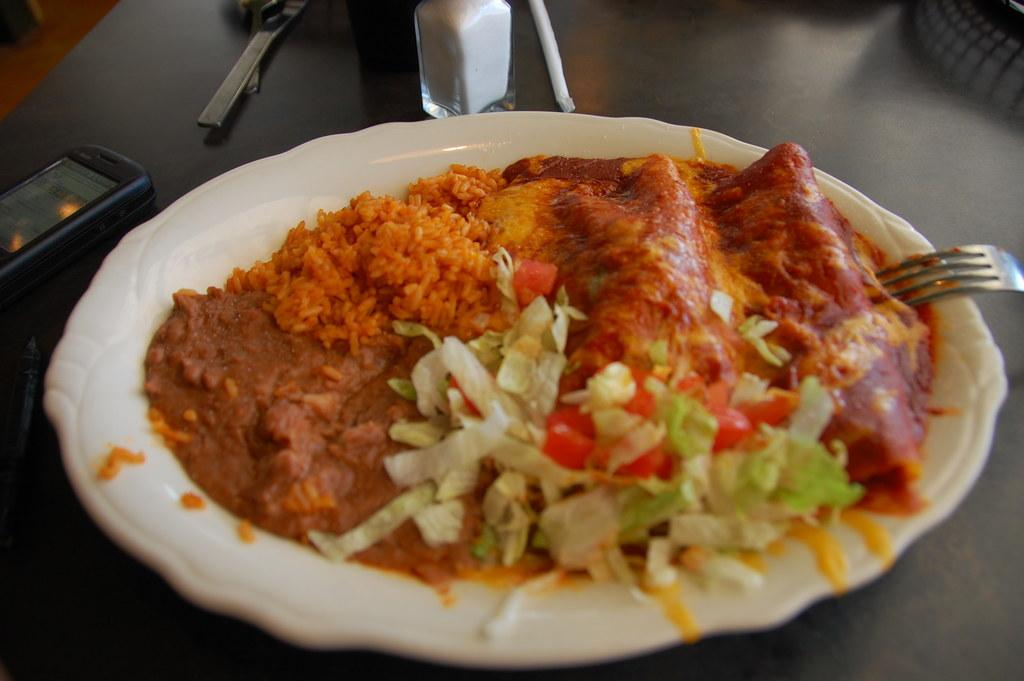What is the main object in the center of the image? There is a table in the center of the image. What items can be seen on the table? On the table, there is a jar, a phone, a fork, a plate, and some food items. Are there any other objects on the table? Yes, there are a few other objects on the table. What type of authority figure can be seen requesting the food items on the table? There is no authority figure present in the image, and no one is requesting the food items. 